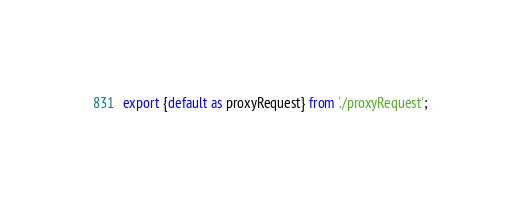<code> <loc_0><loc_0><loc_500><loc_500><_JavaScript_>export {default as proxyRequest} from './proxyRequest';
</code> 